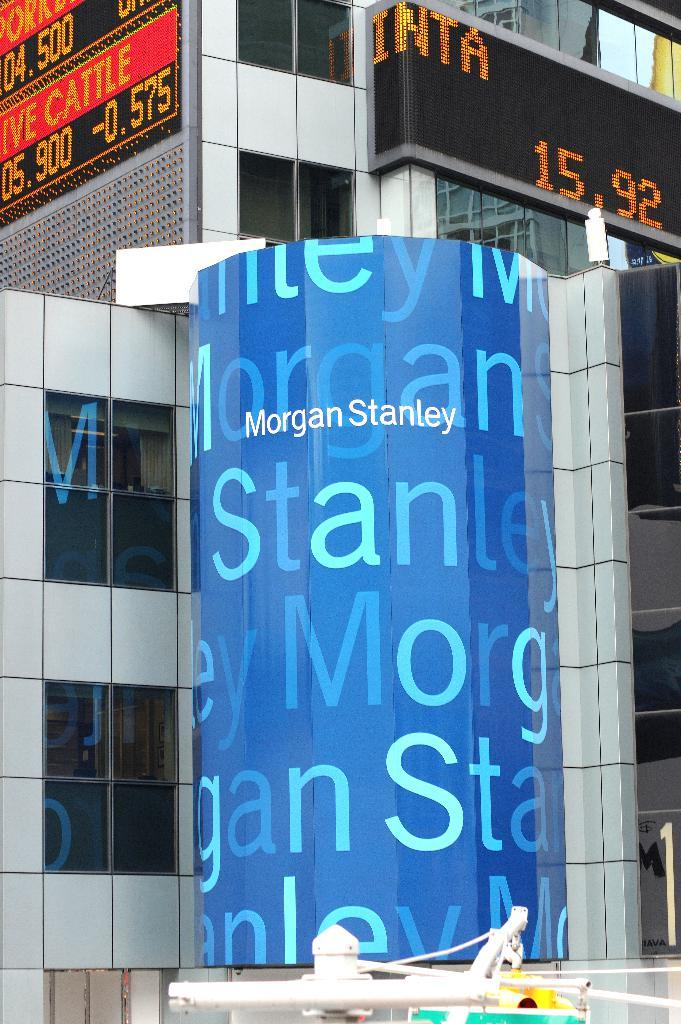What is the main object in the image? There is a board in the image. What type of screens are present in the image? There are LED screens in the image. What is the appearance of the building in the image? The building has glass windows in the image. How many trucks are parked near the building in the image? There are no trucks present in the image. What type of structure is the board attached to in the image? The provided facts do not mention any structure that the board is attached to. 